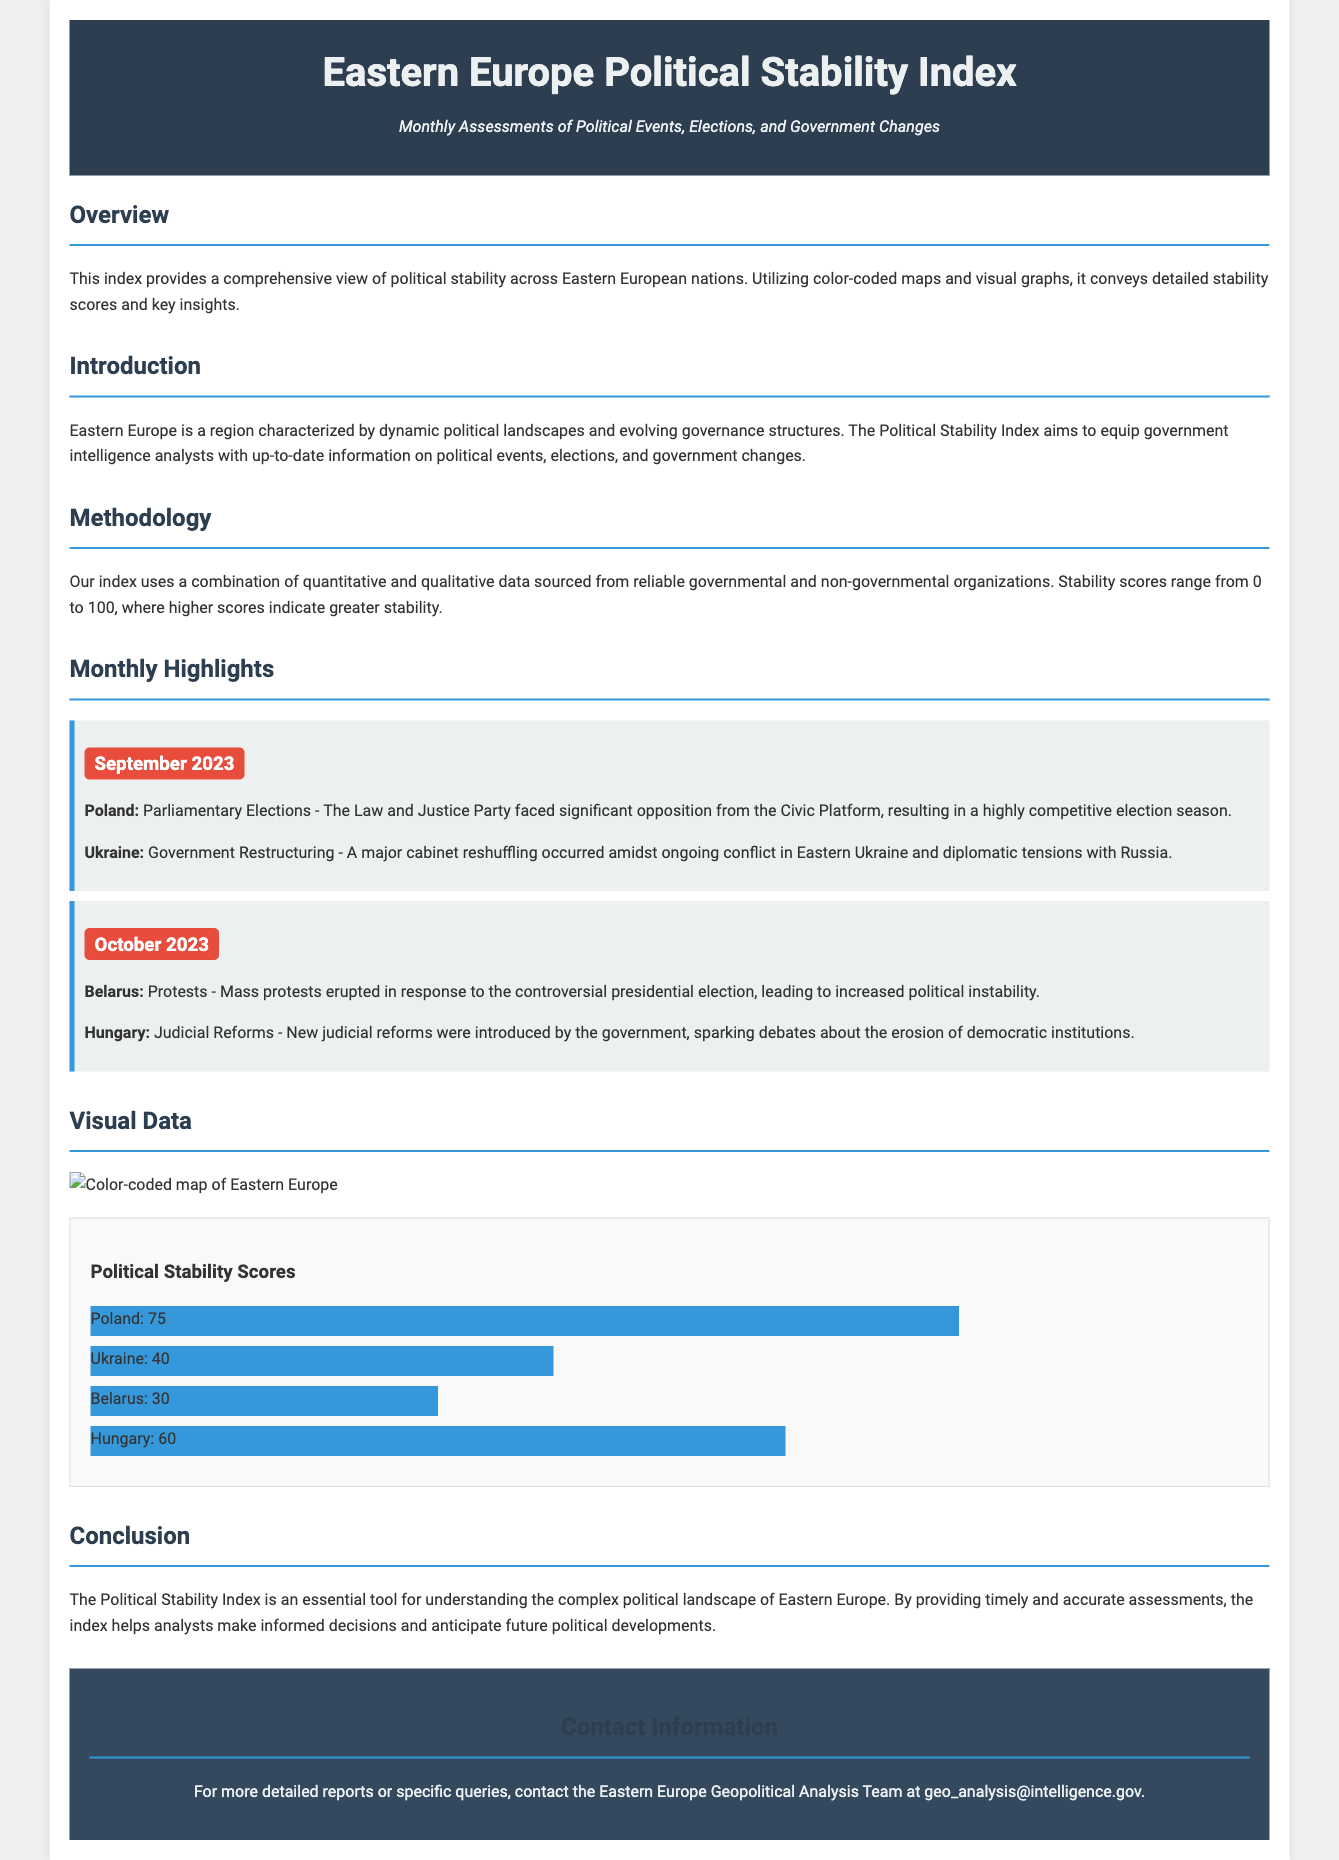What is the title of the document? The title is prominently displayed at the top of the document and is "Eastern Europe Political Stability Index."
Answer: Eastern Europe Political Stability Index What is the main purpose of the Political Stability Index? The overview section explains that the index provides a comprehensive view of political stability across Eastern European nations.
Answer: To provide a comprehensive view of political stability Which country faced significant opposition during the parliamentary elections in September 2023? The monthly highlights section mentions that Poland's Law and Justice Party faced significant opposition from the Civic Platform.
Answer: Poland What political event occurred in Belarus in October 2023? The document states that mass protests erupted in response to the controversial presidential election.
Answer: Mass protests What was the stability score of Ukraine? The chart under the visual data section indicates that Ukraine has a stability score of 40.
Answer: 40 What visual aids are used to convey stability scores? The document describes using color-coded maps and visual graphs to convey the stability scores.
Answer: Color-coded maps and visual graphs Who can be contacted for more detailed reports? The contact section provides an email address for the Eastern Europe Geopolitical Analysis Team for specific queries.
Answer: geo_analysis@intelligence.gov What was a significant event in Ukraine in September 2023? The monthly highlights note that a major cabinet reshuffling took place amidst ongoing conflict in Eastern Ukraine.
Answer: Major cabinet reshuffling 